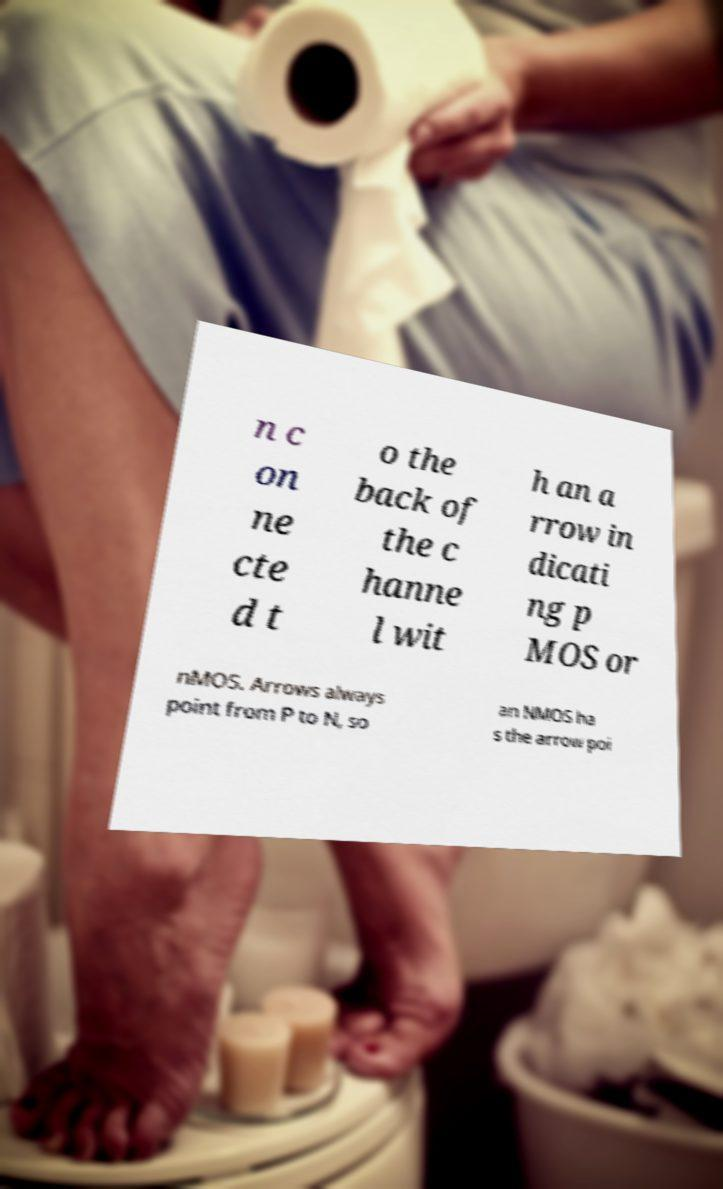Can you accurately transcribe the text from the provided image for me? n c on ne cte d t o the back of the c hanne l wit h an a rrow in dicati ng p MOS or nMOS. Arrows always point from P to N, so an NMOS ha s the arrow poi 